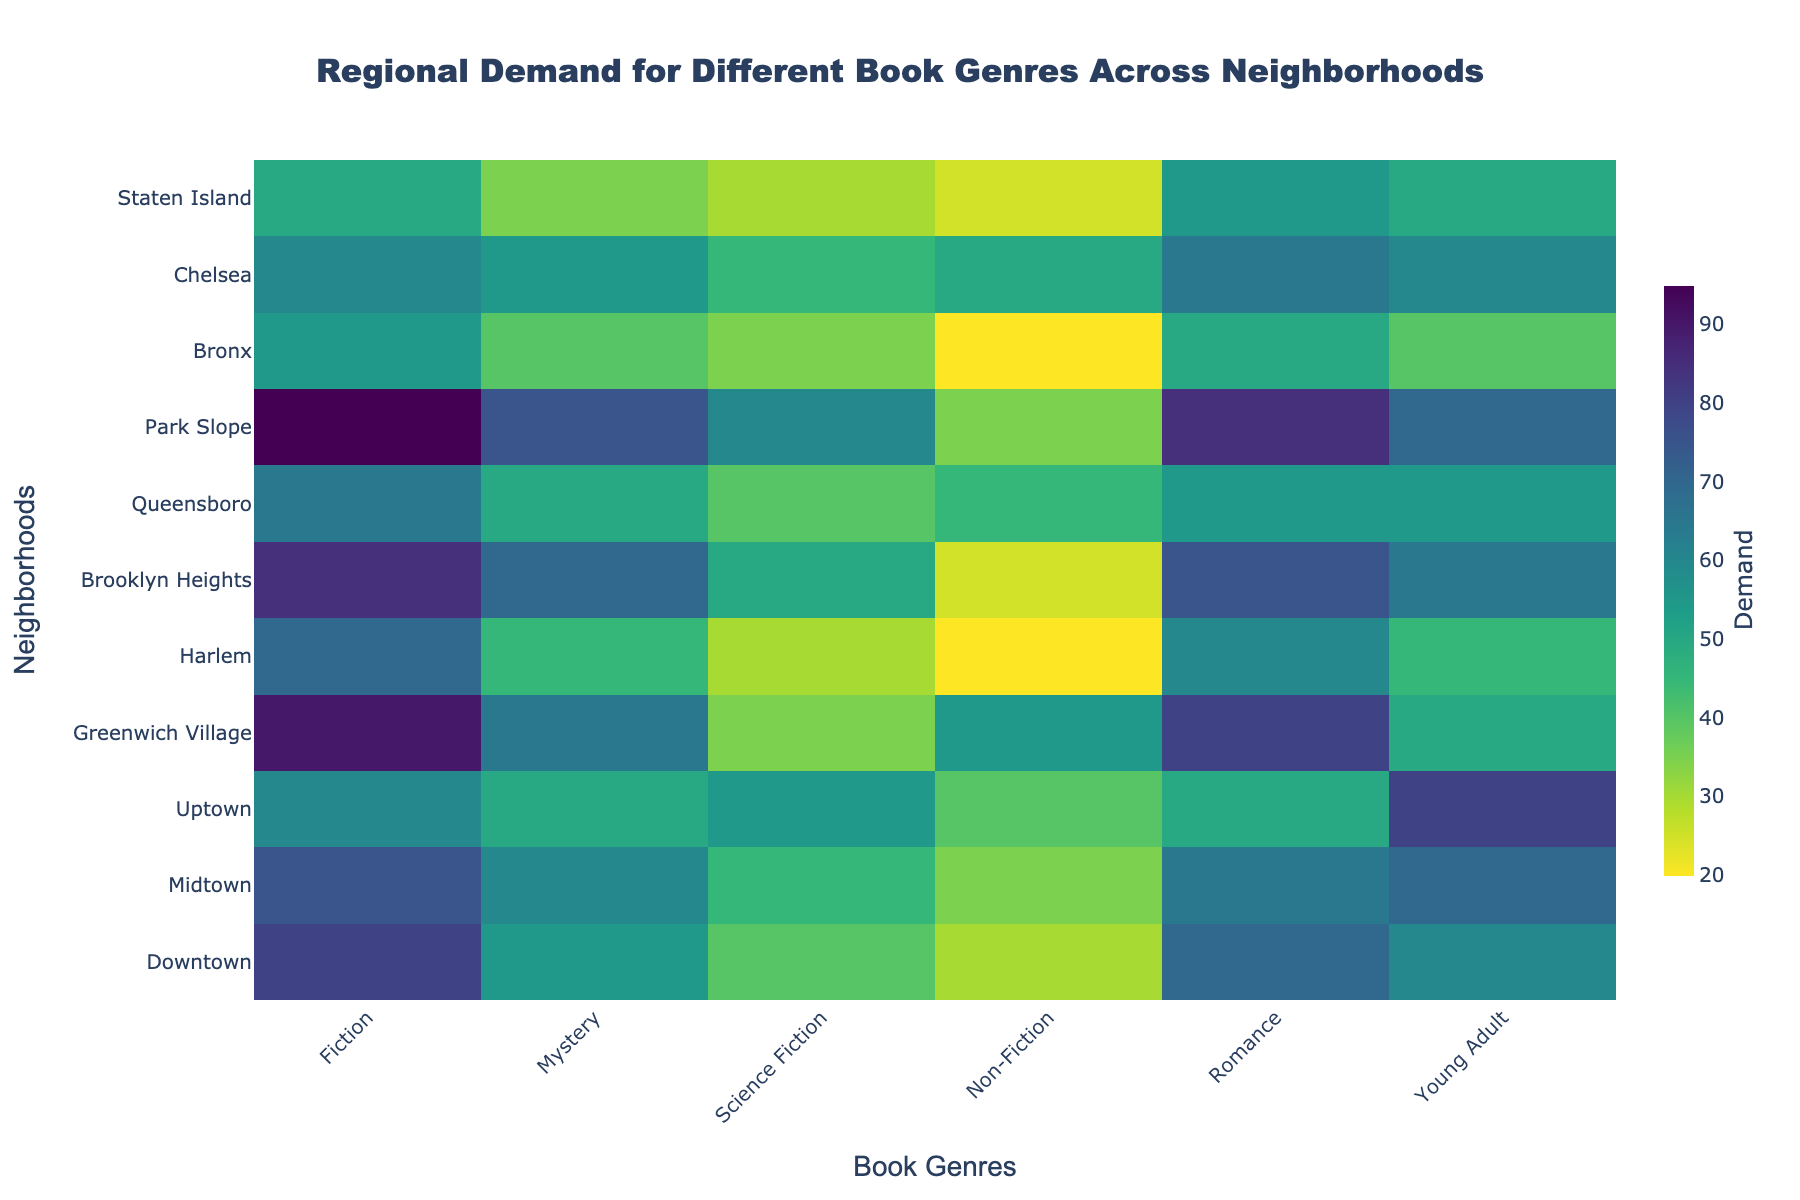Which neighborhood has the highest demand for Fiction? Look at the value corresponding to Fiction for each neighborhood and find the highest number.
Answer: Park Slope What is the general trend of demand for Non-Fiction across the neighborhoods? Analyze the demand values for Non-Fiction in all neighborhoods.
Answer: Generally low Which genre has the most similar demand across Downtown and Uptown? Compare the values for each genre in Downtown and Uptown, and find the ones with the minimal difference.
Answer: Science Fiction Is the demand for Young Adult books consistently high or low across the neighborhoods? Look at the demand values for Young Adult books across all neighborhoods and determine if they are generally high or low.
Answer: Varies How does the demand for Romance in Brooklyn Heights compare to that in Harlem? Look at the values for Romance in Brooklyn Heights and Harlem and compare.
Answer: Higher in Brooklyn Heights What is the average demand for Mystery genre across all neighborhoods? Sum all the demand values for Mystery genre and divide by the number of neighborhoods (11). ((55+60+50+65+45+70+50+75+40+55+35)/11)=56.36
Answer: 56.36 In which neighborhood is the demand for Non-Fiction higher than the demand for Romance? Compare the demand values for Non-Fiction and Romance in each neighborhood to find where Non-Fiction is greater.
Answer: Chelsea What is the difference in demand for Fiction between Greenwich Village and Staten Island? Subtract the value for Fiction in Staten Island from the value for Fiction in Greenwich Village. (90-50)
Answer: 40 Are there any neighborhoods where the demand for Mystery and Science Fiction are equal? Check the values for Mystery and Science Fiction in each neighborhood and see if they match.
Answer: No Which genre has the greatest fluctuation in demand across the neighborhoods? Analyze the variation (range) in demand values for each genre and identify the genre with the highest range.
Answer: Young Adult 